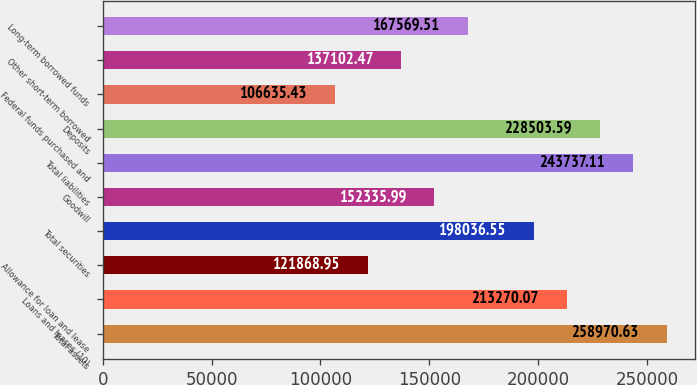Convert chart to OTSL. <chart><loc_0><loc_0><loc_500><loc_500><bar_chart><fcel>Total assets<fcel>Loans and leases (10)<fcel>Allowance for loan and lease<fcel>Total securities<fcel>Goodwill<fcel>Total liabilities<fcel>Deposits<fcel>Federal funds purchased and<fcel>Other short-term borrowed<fcel>Long-term borrowed funds<nl><fcel>258971<fcel>213270<fcel>121869<fcel>198037<fcel>152336<fcel>243737<fcel>228504<fcel>106635<fcel>137102<fcel>167570<nl></chart> 